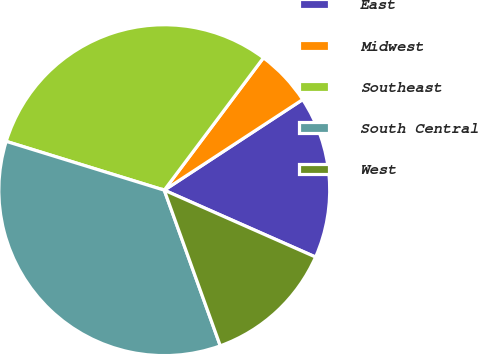Convert chart. <chart><loc_0><loc_0><loc_500><loc_500><pie_chart><fcel>East<fcel>Midwest<fcel>Southeast<fcel>South Central<fcel>West<nl><fcel>15.85%<fcel>5.54%<fcel>30.47%<fcel>35.27%<fcel>12.88%<nl></chart> 